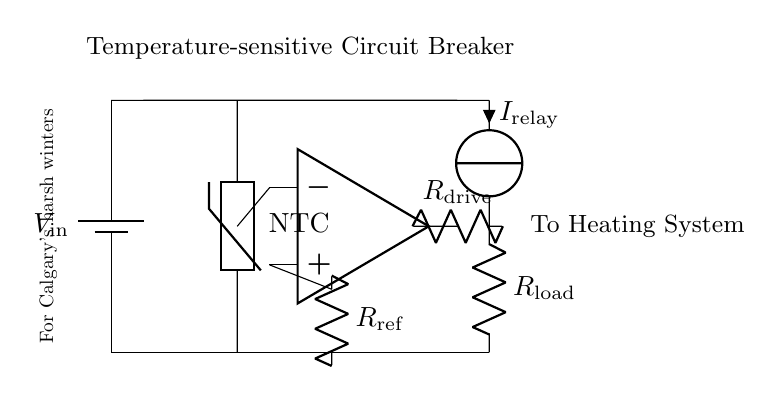What type of circuit is this? This circuit is a temperature-sensitive circuit breaker intended to protect heating systems. The presence of a thermistor, a comparator, and a relay indicates its functionality for temperature monitoring and automatic switching.
Answer: Temperature-sensitive circuit breaker What component measures temperature? The component used to measure temperature in this circuit is the thermistor, indicated as NTC in the diagram. NTC stands for negative temperature coefficient, meaning its resistance decreases as temperature increases.
Answer: Thermistor What does the comparator do? The comparator in this circuit compares the voltage output from the thermistor with a reference voltage provided by the resistor. If the temperature goes beyond a set limit, the comparator triggers the relay.
Answer: It compares voltages What does the relay control? The relay controls the current to the heating system. When activated by the comparator, it will either allow or interrupt the flow of current to the load, thereby protecting the system from overheating.
Answer: Heating system When would the circuit break the connection? The circuit would break the connection when the temperature reading exceeds the predefined threshold voltage set by the reference resistor, activating the relay to interrupt power supply.
Answer: When temperature exceeds threshold What role does the reference resistor play? The reference resistor provides a constant voltage reference for the comparator to determine the maximum allowable temperature. It connects to the non-inverting input of the op-amp, affecting the comparison and operation of the relay.
Answer: Sets reference voltage How is the power supplied in this circuit? Power is supplied by a battery, labeled as V in the circuit, providing the necessary voltage for the entire system to function, including powering the comparator and the relay.
Answer: From the battery 